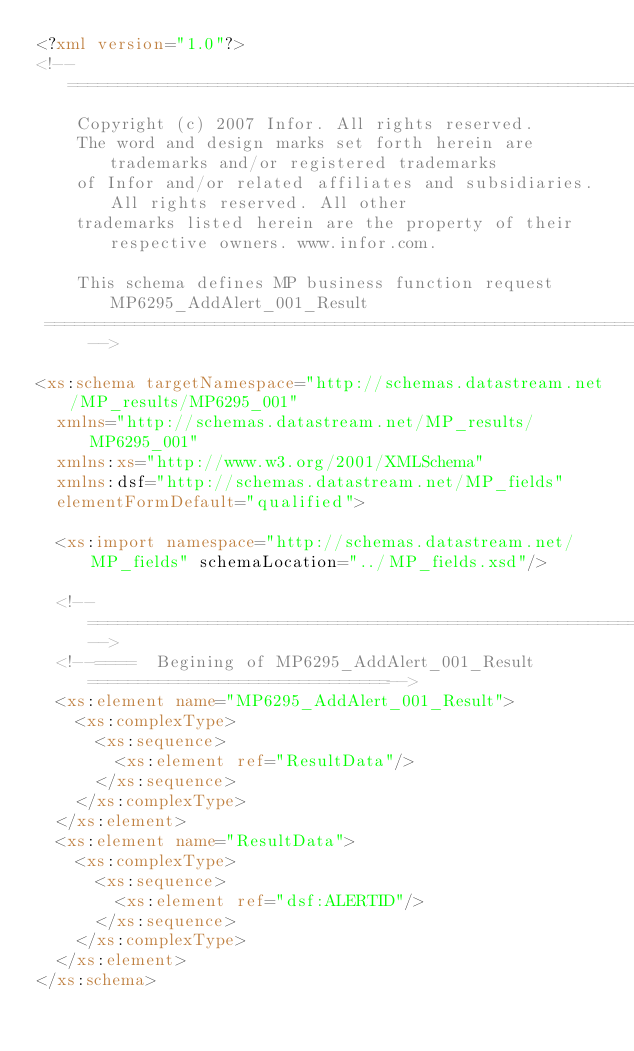<code> <loc_0><loc_0><loc_500><loc_500><_XML_><?xml version="1.0"?>
<!-- ================================================================================
    Copyright (c) 2007 Infor. All rights reserved. 
    The word and design marks set forth herein are trademarks and/or registered trademarks 
    of Infor and/or related affiliates and subsidiaries. All rights reserved. All other 
    trademarks listed herein are the property of their respective owners. www.infor.com.

    This schema defines MP business function request MP6295_AddAlert_001_Result
 ============================================================================= -->

<xs:schema targetNamespace="http://schemas.datastream.net/MP_results/MP6295_001"
	xmlns="http://schemas.datastream.net/MP_results/MP6295_001"
	xmlns:xs="http://www.w3.org/2001/XMLSchema"
	xmlns:dsf="http://schemas.datastream.net/MP_fields" 
	elementFormDefault="qualified">

	<xs:import namespace="http://schemas.datastream.net/MP_fields" schemaLocation="../MP_fields.xsd"/>

	<!--===============================================================================-->
	<!--====  Begining of MP6295_AddAlert_001_Result==============================-->
	<xs:element name="MP6295_AddAlert_001_Result">
		<xs:complexType>
			<xs:sequence>
				<xs:element ref="ResultData"/>
			</xs:sequence>
		</xs:complexType>
	</xs:element>
	<xs:element name="ResultData">
		<xs:complexType>
			<xs:sequence>
				<xs:element ref="dsf:ALERTID"/>
			</xs:sequence>
		</xs:complexType>
	</xs:element>
</xs:schema></code> 